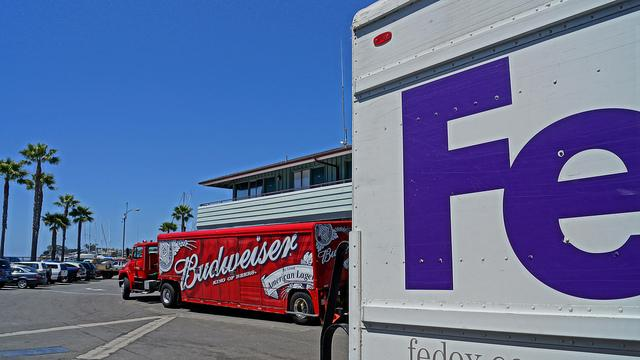What service does the vehicle with the purple letters provide? package delivery 